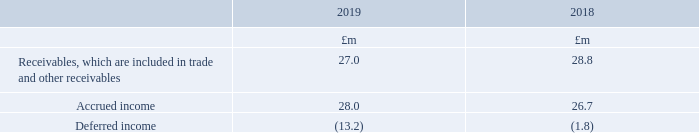Contract balances
The following table provides information about receivables, contract assets and contract liabilities from contracts with customers.
Accrued income relates to the Group’s rights to consideration for services provided but not invoiced at the reporting date. Accrued income is transferred to receivables when invoiced.
Deferred income relates to advanced consideration received for which revenue is recognised as or when services are provided. Included within deferred income is £11.2m (2018: £nil) relating to consideration received from Auto Trader Auto Stock Limited (which forms part of the Group’s joint venture) for the provision of data services (note 16). Revenue relating to this service is recognised on a straight-line basis over a period of 20 years.
What does accrued income relate to? Group’s rights to consideration for services provided but not invoiced at the reporting date. accrued income is transferred to receivables when invoiced. What was  Accrued income in 2019?
Answer scale should be: million. 28.0. What are the components in the table providing information on contract balances? Receivables, which are included in trade and other receivables, accrued income, deferred income. In which year was accrued income larger? 28.0>26.7
Answer: 2019. What was the change in accrued income in 2019 from 2018?
Answer scale should be: million. 28.0-26.7
Answer: 1.3. What was the percentage change in accrued income in 2019 from 2018?
Answer scale should be: percent. (28.0-26.7)/26.7
Answer: 4.87. 